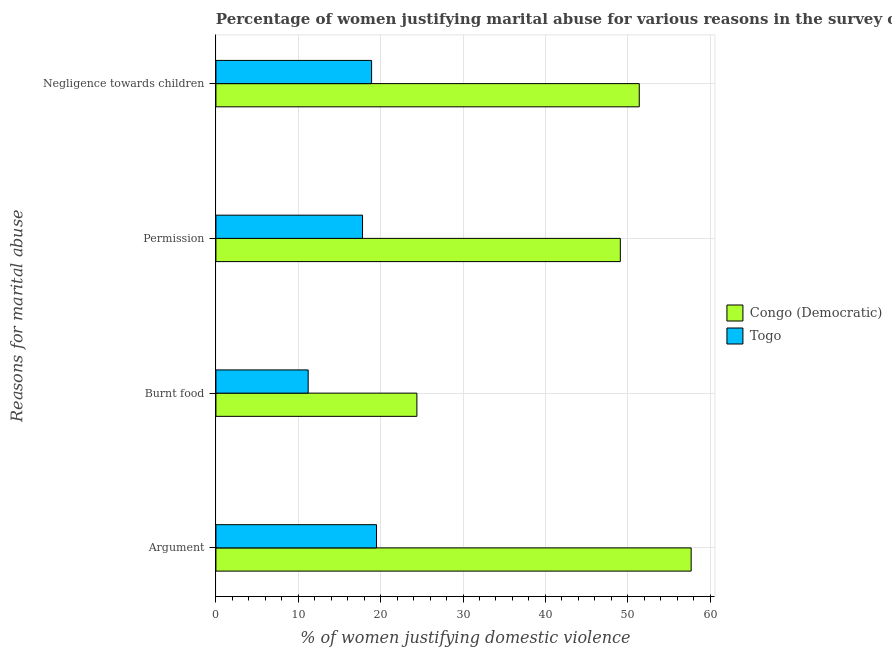How many groups of bars are there?
Provide a short and direct response. 4. How many bars are there on the 4th tick from the top?
Make the answer very short. 2. What is the label of the 2nd group of bars from the top?
Provide a short and direct response. Permission. What is the percentage of women justifying abuse for burning food in Congo (Democratic)?
Offer a very short reply. 24.4. Across all countries, what is the maximum percentage of women justifying abuse for showing negligence towards children?
Offer a very short reply. 51.4. In which country was the percentage of women justifying abuse for showing negligence towards children maximum?
Keep it short and to the point. Congo (Democratic). In which country was the percentage of women justifying abuse for going without permission minimum?
Ensure brevity in your answer.  Togo. What is the total percentage of women justifying abuse for burning food in the graph?
Give a very brief answer. 35.6. What is the difference between the percentage of women justifying abuse for going without permission in Congo (Democratic) and that in Togo?
Your answer should be very brief. 31.3. What is the difference between the percentage of women justifying abuse for showing negligence towards children in Togo and the percentage of women justifying abuse for going without permission in Congo (Democratic)?
Keep it short and to the point. -30.2. What is the average percentage of women justifying abuse for burning food per country?
Offer a very short reply. 17.8. What is the difference between the percentage of women justifying abuse for going without permission and percentage of women justifying abuse in the case of an argument in Togo?
Provide a succinct answer. -1.7. In how many countries, is the percentage of women justifying abuse for burning food greater than 16 %?
Provide a short and direct response. 1. What is the ratio of the percentage of women justifying abuse for showing negligence towards children in Togo to that in Congo (Democratic)?
Your answer should be compact. 0.37. Is the difference between the percentage of women justifying abuse in the case of an argument in Togo and Congo (Democratic) greater than the difference between the percentage of women justifying abuse for burning food in Togo and Congo (Democratic)?
Your answer should be compact. No. What is the difference between the highest and the second highest percentage of women justifying abuse for going without permission?
Keep it short and to the point. 31.3. What is the difference between the highest and the lowest percentage of women justifying abuse in the case of an argument?
Your response must be concise. 38.2. Is the sum of the percentage of women justifying abuse for showing negligence towards children in Congo (Democratic) and Togo greater than the maximum percentage of women justifying abuse for going without permission across all countries?
Provide a succinct answer. Yes. What does the 1st bar from the top in Permission represents?
Offer a very short reply. Togo. What does the 2nd bar from the bottom in Permission represents?
Your response must be concise. Togo. How many bars are there?
Ensure brevity in your answer.  8. How many countries are there in the graph?
Provide a short and direct response. 2. What is the difference between two consecutive major ticks on the X-axis?
Offer a very short reply. 10. Are the values on the major ticks of X-axis written in scientific E-notation?
Make the answer very short. No. Where does the legend appear in the graph?
Offer a terse response. Center right. How many legend labels are there?
Your answer should be very brief. 2. How are the legend labels stacked?
Your response must be concise. Vertical. What is the title of the graph?
Provide a succinct answer. Percentage of women justifying marital abuse for various reasons in the survey of 2014. What is the label or title of the X-axis?
Your answer should be compact. % of women justifying domestic violence. What is the label or title of the Y-axis?
Provide a short and direct response. Reasons for marital abuse. What is the % of women justifying domestic violence in Congo (Democratic) in Argument?
Provide a succinct answer. 57.7. What is the % of women justifying domestic violence in Congo (Democratic) in Burnt food?
Your answer should be very brief. 24.4. What is the % of women justifying domestic violence in Togo in Burnt food?
Give a very brief answer. 11.2. What is the % of women justifying domestic violence in Congo (Democratic) in Permission?
Your answer should be compact. 49.1. What is the % of women justifying domestic violence of Congo (Democratic) in Negligence towards children?
Provide a succinct answer. 51.4. Across all Reasons for marital abuse, what is the maximum % of women justifying domestic violence in Congo (Democratic)?
Make the answer very short. 57.7. Across all Reasons for marital abuse, what is the minimum % of women justifying domestic violence of Congo (Democratic)?
Your answer should be very brief. 24.4. What is the total % of women justifying domestic violence in Congo (Democratic) in the graph?
Offer a very short reply. 182.6. What is the total % of women justifying domestic violence in Togo in the graph?
Keep it short and to the point. 67.4. What is the difference between the % of women justifying domestic violence of Congo (Democratic) in Argument and that in Burnt food?
Make the answer very short. 33.3. What is the difference between the % of women justifying domestic violence of Togo in Argument and that in Burnt food?
Provide a short and direct response. 8.3. What is the difference between the % of women justifying domestic violence in Congo (Democratic) in Argument and that in Permission?
Ensure brevity in your answer.  8.6. What is the difference between the % of women justifying domestic violence of Togo in Argument and that in Permission?
Ensure brevity in your answer.  1.7. What is the difference between the % of women justifying domestic violence of Congo (Democratic) in Argument and that in Negligence towards children?
Make the answer very short. 6.3. What is the difference between the % of women justifying domestic violence of Congo (Democratic) in Burnt food and that in Permission?
Offer a terse response. -24.7. What is the difference between the % of women justifying domestic violence of Togo in Burnt food and that in Permission?
Give a very brief answer. -6.6. What is the difference between the % of women justifying domestic violence of Togo in Burnt food and that in Negligence towards children?
Your answer should be compact. -7.7. What is the difference between the % of women justifying domestic violence in Congo (Democratic) in Permission and that in Negligence towards children?
Offer a terse response. -2.3. What is the difference between the % of women justifying domestic violence of Congo (Democratic) in Argument and the % of women justifying domestic violence of Togo in Burnt food?
Offer a terse response. 46.5. What is the difference between the % of women justifying domestic violence of Congo (Democratic) in Argument and the % of women justifying domestic violence of Togo in Permission?
Give a very brief answer. 39.9. What is the difference between the % of women justifying domestic violence in Congo (Democratic) in Argument and the % of women justifying domestic violence in Togo in Negligence towards children?
Your response must be concise. 38.8. What is the difference between the % of women justifying domestic violence in Congo (Democratic) in Permission and the % of women justifying domestic violence in Togo in Negligence towards children?
Offer a terse response. 30.2. What is the average % of women justifying domestic violence of Congo (Democratic) per Reasons for marital abuse?
Make the answer very short. 45.65. What is the average % of women justifying domestic violence of Togo per Reasons for marital abuse?
Provide a succinct answer. 16.85. What is the difference between the % of women justifying domestic violence in Congo (Democratic) and % of women justifying domestic violence in Togo in Argument?
Keep it short and to the point. 38.2. What is the difference between the % of women justifying domestic violence of Congo (Democratic) and % of women justifying domestic violence of Togo in Permission?
Give a very brief answer. 31.3. What is the difference between the % of women justifying domestic violence in Congo (Democratic) and % of women justifying domestic violence in Togo in Negligence towards children?
Your response must be concise. 32.5. What is the ratio of the % of women justifying domestic violence in Congo (Democratic) in Argument to that in Burnt food?
Your response must be concise. 2.36. What is the ratio of the % of women justifying domestic violence in Togo in Argument to that in Burnt food?
Keep it short and to the point. 1.74. What is the ratio of the % of women justifying domestic violence in Congo (Democratic) in Argument to that in Permission?
Ensure brevity in your answer.  1.18. What is the ratio of the % of women justifying domestic violence of Togo in Argument to that in Permission?
Provide a short and direct response. 1.1. What is the ratio of the % of women justifying domestic violence in Congo (Democratic) in Argument to that in Negligence towards children?
Make the answer very short. 1.12. What is the ratio of the % of women justifying domestic violence in Togo in Argument to that in Negligence towards children?
Your answer should be compact. 1.03. What is the ratio of the % of women justifying domestic violence of Congo (Democratic) in Burnt food to that in Permission?
Offer a terse response. 0.5. What is the ratio of the % of women justifying domestic violence of Togo in Burnt food to that in Permission?
Ensure brevity in your answer.  0.63. What is the ratio of the % of women justifying domestic violence in Congo (Democratic) in Burnt food to that in Negligence towards children?
Offer a terse response. 0.47. What is the ratio of the % of women justifying domestic violence of Togo in Burnt food to that in Negligence towards children?
Offer a very short reply. 0.59. What is the ratio of the % of women justifying domestic violence of Congo (Democratic) in Permission to that in Negligence towards children?
Provide a succinct answer. 0.96. What is the ratio of the % of women justifying domestic violence of Togo in Permission to that in Negligence towards children?
Give a very brief answer. 0.94. What is the difference between the highest and the second highest % of women justifying domestic violence in Togo?
Give a very brief answer. 0.6. What is the difference between the highest and the lowest % of women justifying domestic violence in Congo (Democratic)?
Provide a succinct answer. 33.3. What is the difference between the highest and the lowest % of women justifying domestic violence in Togo?
Your response must be concise. 8.3. 